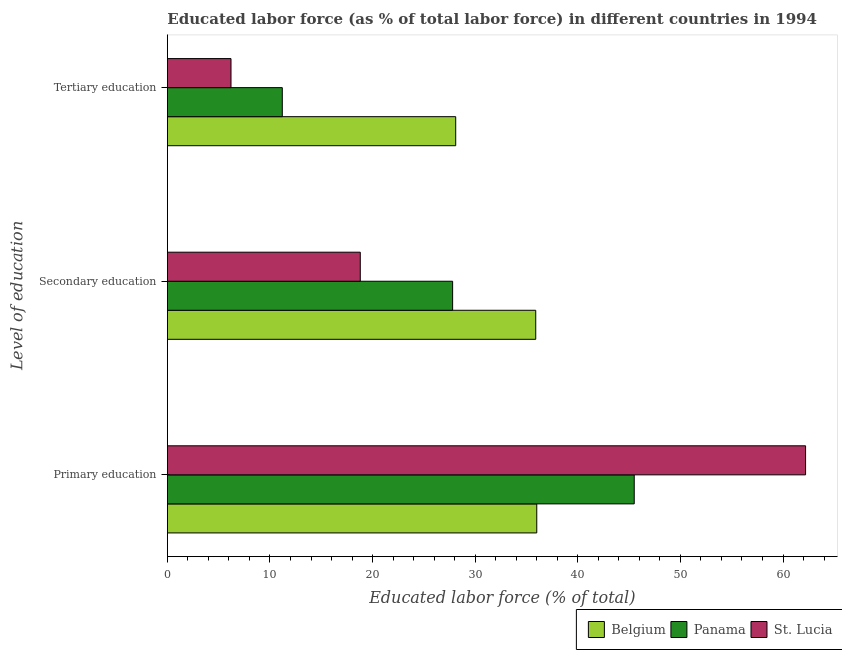How many bars are there on the 1st tick from the bottom?
Make the answer very short. 3. What is the label of the 2nd group of bars from the top?
Your answer should be very brief. Secondary education. What is the percentage of labor force who received tertiary education in St. Lucia?
Provide a succinct answer. 6.2. Across all countries, what is the maximum percentage of labor force who received primary education?
Make the answer very short. 62.2. In which country was the percentage of labor force who received secondary education maximum?
Your response must be concise. Belgium. What is the total percentage of labor force who received secondary education in the graph?
Keep it short and to the point. 82.5. What is the difference between the percentage of labor force who received tertiary education in St. Lucia and that in Belgium?
Your answer should be very brief. -21.9. What is the difference between the percentage of labor force who received primary education in St. Lucia and the percentage of labor force who received tertiary education in Panama?
Provide a succinct answer. 51. What is the average percentage of labor force who received primary education per country?
Offer a terse response. 47.9. What is the difference between the percentage of labor force who received secondary education and percentage of labor force who received primary education in Panama?
Your response must be concise. -17.7. What is the ratio of the percentage of labor force who received tertiary education in St. Lucia to that in Panama?
Your answer should be compact. 0.55. Is the percentage of labor force who received secondary education in St. Lucia less than that in Panama?
Provide a succinct answer. Yes. What is the difference between the highest and the second highest percentage of labor force who received tertiary education?
Provide a succinct answer. 16.9. What is the difference between the highest and the lowest percentage of labor force who received primary education?
Your answer should be compact. 26.2. In how many countries, is the percentage of labor force who received primary education greater than the average percentage of labor force who received primary education taken over all countries?
Give a very brief answer. 1. Is the sum of the percentage of labor force who received secondary education in Panama and Belgium greater than the maximum percentage of labor force who received primary education across all countries?
Provide a succinct answer. Yes. How many countries are there in the graph?
Offer a very short reply. 3. What is the difference between two consecutive major ticks on the X-axis?
Your answer should be very brief. 10. Does the graph contain any zero values?
Your answer should be compact. No. Does the graph contain grids?
Provide a succinct answer. No. How are the legend labels stacked?
Your response must be concise. Horizontal. What is the title of the graph?
Your response must be concise. Educated labor force (as % of total labor force) in different countries in 1994. Does "High income" appear as one of the legend labels in the graph?
Offer a very short reply. No. What is the label or title of the X-axis?
Give a very brief answer. Educated labor force (% of total). What is the label or title of the Y-axis?
Your answer should be compact. Level of education. What is the Educated labor force (% of total) of Panama in Primary education?
Keep it short and to the point. 45.5. What is the Educated labor force (% of total) of St. Lucia in Primary education?
Your answer should be compact. 62.2. What is the Educated labor force (% of total) of Belgium in Secondary education?
Make the answer very short. 35.9. What is the Educated labor force (% of total) of Panama in Secondary education?
Make the answer very short. 27.8. What is the Educated labor force (% of total) in St. Lucia in Secondary education?
Provide a short and direct response. 18.8. What is the Educated labor force (% of total) of Belgium in Tertiary education?
Your response must be concise. 28.1. What is the Educated labor force (% of total) of Panama in Tertiary education?
Provide a succinct answer. 11.2. What is the Educated labor force (% of total) in St. Lucia in Tertiary education?
Keep it short and to the point. 6.2. Across all Level of education, what is the maximum Educated labor force (% of total) in Panama?
Provide a succinct answer. 45.5. Across all Level of education, what is the maximum Educated labor force (% of total) in St. Lucia?
Your answer should be compact. 62.2. Across all Level of education, what is the minimum Educated labor force (% of total) in Belgium?
Offer a terse response. 28.1. Across all Level of education, what is the minimum Educated labor force (% of total) of Panama?
Provide a short and direct response. 11.2. Across all Level of education, what is the minimum Educated labor force (% of total) of St. Lucia?
Your answer should be very brief. 6.2. What is the total Educated labor force (% of total) of Belgium in the graph?
Offer a very short reply. 100. What is the total Educated labor force (% of total) in Panama in the graph?
Provide a succinct answer. 84.5. What is the total Educated labor force (% of total) in St. Lucia in the graph?
Offer a terse response. 87.2. What is the difference between the Educated labor force (% of total) of Belgium in Primary education and that in Secondary education?
Ensure brevity in your answer.  0.1. What is the difference between the Educated labor force (% of total) in St. Lucia in Primary education and that in Secondary education?
Your answer should be compact. 43.4. What is the difference between the Educated labor force (% of total) in Panama in Primary education and that in Tertiary education?
Offer a terse response. 34.3. What is the difference between the Educated labor force (% of total) in St. Lucia in Primary education and that in Tertiary education?
Your answer should be very brief. 56. What is the difference between the Educated labor force (% of total) in St. Lucia in Secondary education and that in Tertiary education?
Keep it short and to the point. 12.6. What is the difference between the Educated labor force (% of total) in Belgium in Primary education and the Educated labor force (% of total) in St. Lucia in Secondary education?
Give a very brief answer. 17.2. What is the difference between the Educated labor force (% of total) of Panama in Primary education and the Educated labor force (% of total) of St. Lucia in Secondary education?
Your answer should be compact. 26.7. What is the difference between the Educated labor force (% of total) in Belgium in Primary education and the Educated labor force (% of total) in Panama in Tertiary education?
Offer a very short reply. 24.8. What is the difference between the Educated labor force (% of total) in Belgium in Primary education and the Educated labor force (% of total) in St. Lucia in Tertiary education?
Provide a short and direct response. 29.8. What is the difference between the Educated labor force (% of total) in Panama in Primary education and the Educated labor force (% of total) in St. Lucia in Tertiary education?
Your answer should be compact. 39.3. What is the difference between the Educated labor force (% of total) in Belgium in Secondary education and the Educated labor force (% of total) in Panama in Tertiary education?
Ensure brevity in your answer.  24.7. What is the difference between the Educated labor force (% of total) in Belgium in Secondary education and the Educated labor force (% of total) in St. Lucia in Tertiary education?
Your answer should be very brief. 29.7. What is the difference between the Educated labor force (% of total) of Panama in Secondary education and the Educated labor force (% of total) of St. Lucia in Tertiary education?
Your answer should be very brief. 21.6. What is the average Educated labor force (% of total) in Belgium per Level of education?
Provide a short and direct response. 33.33. What is the average Educated labor force (% of total) of Panama per Level of education?
Offer a terse response. 28.17. What is the average Educated labor force (% of total) in St. Lucia per Level of education?
Your answer should be compact. 29.07. What is the difference between the Educated labor force (% of total) of Belgium and Educated labor force (% of total) of St. Lucia in Primary education?
Provide a short and direct response. -26.2. What is the difference between the Educated labor force (% of total) in Panama and Educated labor force (% of total) in St. Lucia in Primary education?
Provide a succinct answer. -16.7. What is the difference between the Educated labor force (% of total) of Belgium and Educated labor force (% of total) of Panama in Secondary education?
Give a very brief answer. 8.1. What is the difference between the Educated labor force (% of total) of Belgium and Educated labor force (% of total) of St. Lucia in Secondary education?
Offer a very short reply. 17.1. What is the difference between the Educated labor force (% of total) in Belgium and Educated labor force (% of total) in Panama in Tertiary education?
Ensure brevity in your answer.  16.9. What is the difference between the Educated labor force (% of total) in Belgium and Educated labor force (% of total) in St. Lucia in Tertiary education?
Your answer should be compact. 21.9. What is the difference between the Educated labor force (% of total) of Panama and Educated labor force (% of total) of St. Lucia in Tertiary education?
Offer a very short reply. 5. What is the ratio of the Educated labor force (% of total) of Panama in Primary education to that in Secondary education?
Give a very brief answer. 1.64. What is the ratio of the Educated labor force (% of total) in St. Lucia in Primary education to that in Secondary education?
Give a very brief answer. 3.31. What is the ratio of the Educated labor force (% of total) of Belgium in Primary education to that in Tertiary education?
Offer a very short reply. 1.28. What is the ratio of the Educated labor force (% of total) in Panama in Primary education to that in Tertiary education?
Your answer should be compact. 4.06. What is the ratio of the Educated labor force (% of total) of St. Lucia in Primary education to that in Tertiary education?
Make the answer very short. 10.03. What is the ratio of the Educated labor force (% of total) of Belgium in Secondary education to that in Tertiary education?
Your response must be concise. 1.28. What is the ratio of the Educated labor force (% of total) of Panama in Secondary education to that in Tertiary education?
Give a very brief answer. 2.48. What is the ratio of the Educated labor force (% of total) in St. Lucia in Secondary education to that in Tertiary education?
Make the answer very short. 3.03. What is the difference between the highest and the second highest Educated labor force (% of total) in Panama?
Your response must be concise. 17.7. What is the difference between the highest and the second highest Educated labor force (% of total) of St. Lucia?
Provide a short and direct response. 43.4. What is the difference between the highest and the lowest Educated labor force (% of total) in Panama?
Your answer should be very brief. 34.3. 